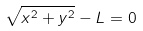<formula> <loc_0><loc_0><loc_500><loc_500>\sqrt { x ^ { 2 } + y ^ { 2 } } - L = 0</formula> 